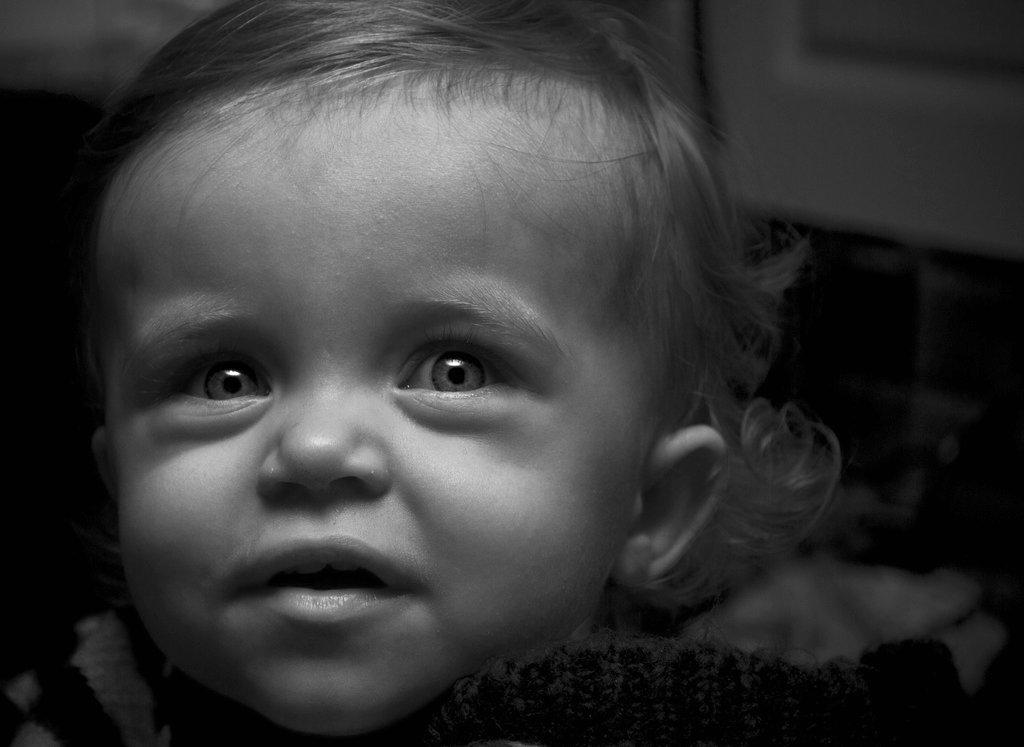What is the main subject of the image? The main subject of the image is a kid. Can you describe the background of the image? The background of the image is blurry. What type of loaf can be seen in the image? There is no loaf present in the image. What kind of flesh can be seen on the kid in the image? There is no flesh visible on the kid in the image, as it is not a realistic or detailed depiction of a child. 